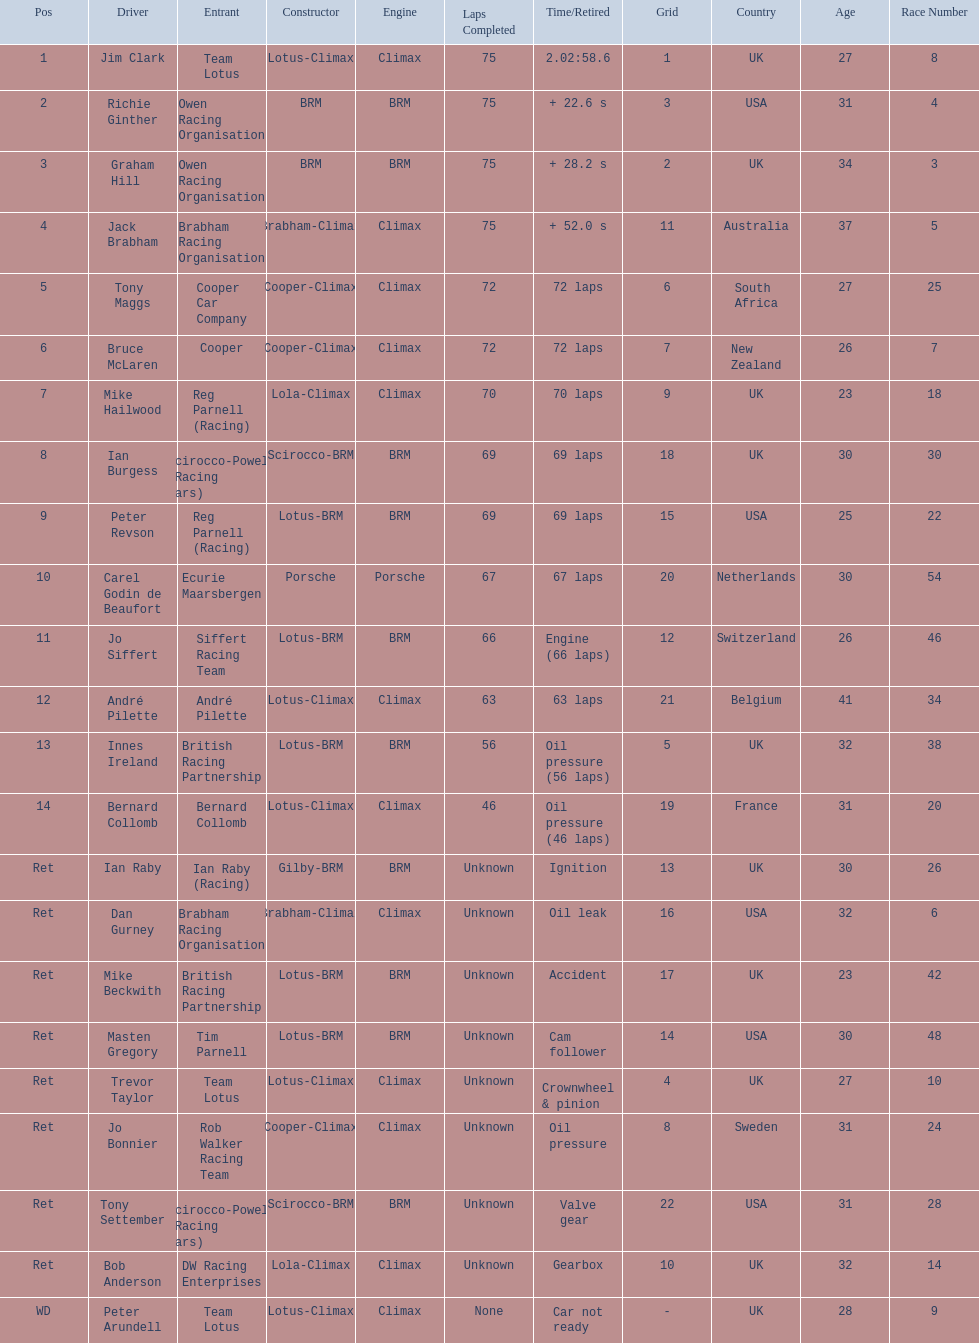Who were the two that that a similar problem? Innes Ireland. What was their common problem? Oil pressure. 